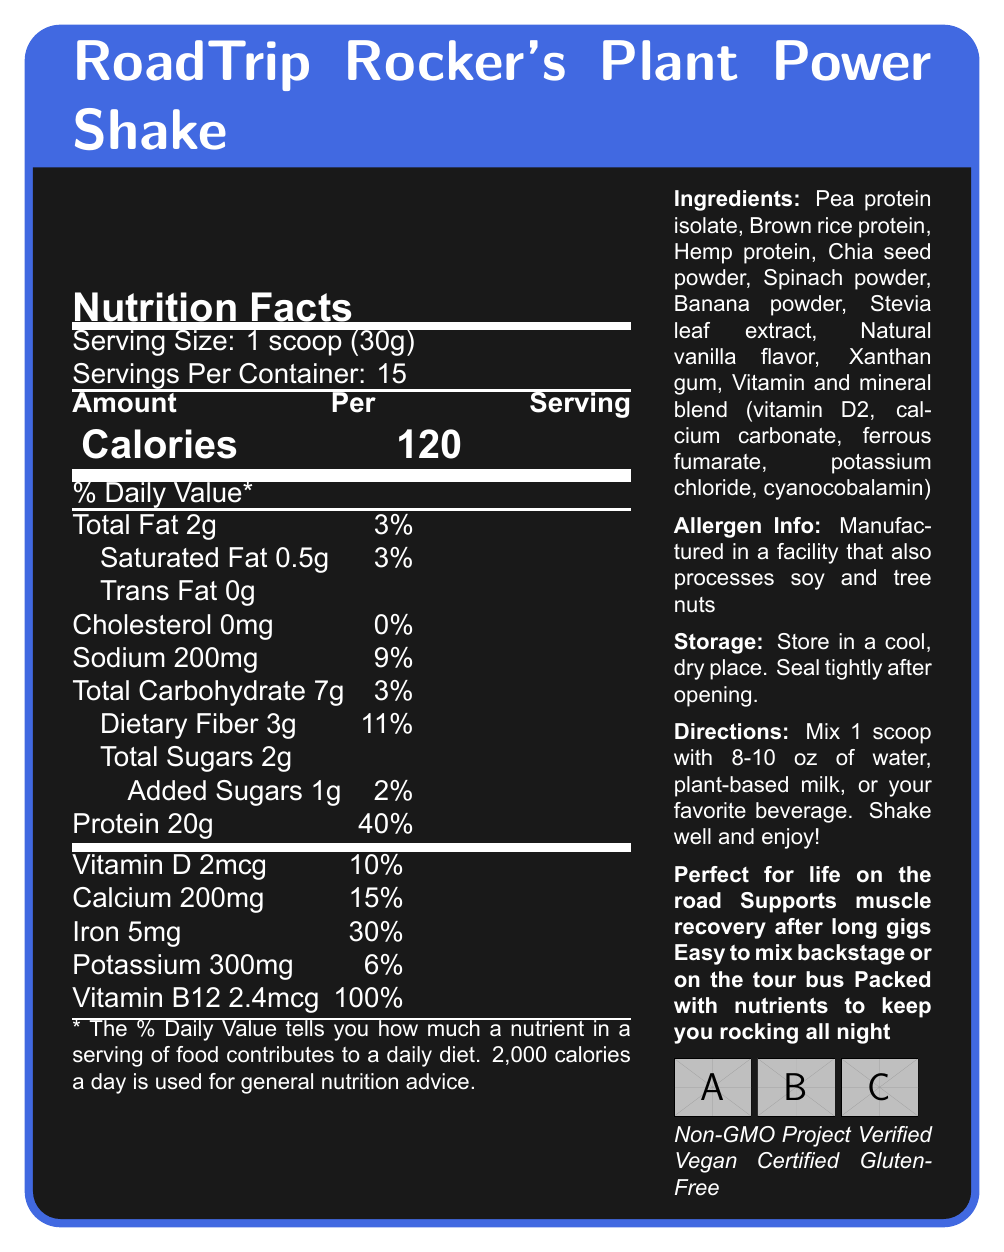what is the serving size for RoadTrip Rocker's Plant Power Shake? The serving size is specified as "1 scoop (30g)" in the document.
Answer: 1 scoop (30g) how many servings are there per container? The document states that there are 15 servings per container.
Answer: 15 how much protein is in one serving of the shake? The protein content per serving is listed as 20g.
Answer: 20g what is the amount of dietary fiber in each serving? The document indicates that each serving contains 3g of dietary fiber.
Answer: 3g what percentage of the daily value of vitamin B12 does one serving provide? The document shows that one serving provides 100% of the daily value of vitamin B12.
Answer: 100% what allergens might the shake contain? A. Eggs B. Peanuts C. Soy and tree nuts D. Wheat The allergen info section states that the product is manufactured in a facility that also processes soy and tree nuts.
Answer: C how many calories are there per serving of the shake? A. 90 B. 120 C. 150 D. 200 According to the document, each serving contains 120 calories.
Answer: B which of the following ingredients is NOT present in the shake? A. Pea protein isolate B. Spinach powder C. Whey protein D. Chia seed powder The ingredient list does not mention whey protein.
Answer: C does the shake contain any cholesterol? The document clearly states that the cholesterol content is 0mg.
Answer: No what is one of the marketing claims for this shake? One of the claims mentioned in the document is that the shake "Supports muscle recovery after long gigs."
Answer: Supports muscle recovery after long gigs how should the shake be stored? The storage instructions specify to store the shake in a cool, dry place and to seal it tightly after opening.
Answer: Store in a cool, dry place. Seal tightly after opening. what certifications does the product have? The product has the certifications: Non-GMO Project Verified, Vegan Certified, and Gluten-Free.
Answer: Non-GMO Project Verified, Vegan Certified, Gluten-Free how much added sugar is in one serving? The document indicates that there is 1g of added sugar per serving.
Answer: 1g which vitamins or minerals are provided in more than 20% of the daily value? A. Vitamin D B. Calcium C. Iron D. Potassium Iron provides 30% of the daily value per serving, which is more than 20%.
Answer: C is the shake easy to prepare while on tour? The document states that the shake is "Easy to mix backstage or on the tour bus," making it suitable for on-the-go preparation.
Answer: Yes what is the main idea of the document? The document predominantly focuses on describing the nutritional content, ingredient list, allergen information, storage instructions, and marketing claims for the RoadTrip Rocker's Plant Power Shake, emphasizing its suitability for musicians on the road and its various certifications.
Answer: The document provides nutritional information, ingredients, and other details for RoadTrip Rocker's Plant Power Shake, a plant-based protein shake designed for touring musicians, highlighting its ease of use, nutrient content, and certifications. what is the recommended liquid volume to mix with one scoop of the shake? The directions suggest mixing 1 scoop with 8-10 oz of water, plant-based milk, or another beverage.
Answer: 8-10 oz does the shake provide a good source of calcium? The document shows that each serving contains 200mg of calcium, which accounts for 15% of the daily value, indicating it is a good source.
Answer: Yes, it provides 15% of the daily value. what is the product name? The product name is stated at the top of the document as "RoadTrip Rocker's Plant Power Shake."
Answer: RoadTrip Rocker's Plant Power Shake what is the percentage of daily value for sodium in one serving? The document states that the sodium content for one serving is 200mg, which is 9% of the daily value.
Answer: 9% is the product gluten-free? The certifications section lists "Gluten-Free" as one of the certifications of the product.
Answer: Yes from which ingredient does the shake get its flavor? The ingredient list includes natural vanilla flavor, which is used to flavor the shake.
Answer: Natural vanilla flavor what is the source of the vitamins included in the shake? The vitamins and minerals are provided by a blend that includes vitamin D2, calcium carbonate, ferrous fumarate, potassium chloride, and cyanocobalamin.
Answer: Vitamin and mineral blend (vitamin D2, calcium carbonate, ferrous fumarate, potassium chloride, cyanocobalamin) is the amount of potassium more than that of calcium? Calcium is 200mg per serving, while potassium is 300mg per serving. Thus, potassium is more than calcium.
Answer: No is RoadTrip Rocker's Plant Power Shake suitable for vegetarians? The document indicates that the shake is certified vegan, making it suitable for vegetarians.
Answer: Yes 